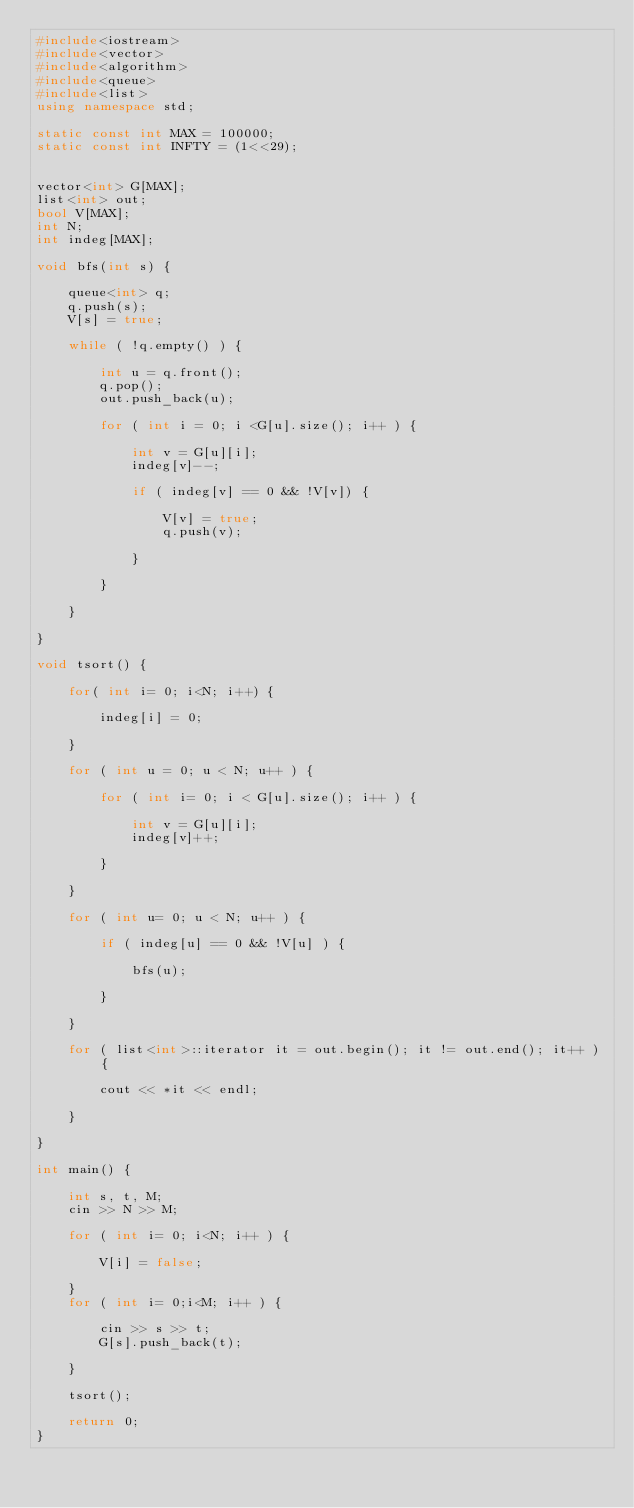Convert code to text. <code><loc_0><loc_0><loc_500><loc_500><_C++_>#include<iostream>
#include<vector>
#include<algorithm>
#include<queue>
#include<list>
using namespace std;

static const int MAX = 100000;
static const int INFTY = (1<<29);


vector<int> G[MAX];
list<int> out;
bool V[MAX];
int N;
int indeg[MAX];

void bfs(int s) {
    
    queue<int> q;
    q.push(s);
    V[s] = true;
    
    while ( !q.empty() ) {
        
        int u = q.front();
        q.pop();
        out.push_back(u);
        
        for ( int i = 0; i <G[u].size(); i++ ) {
            
            int v = G[u][i];
            indeg[v]--;
            
            if ( indeg[v] == 0 && !V[v]) {
                
                V[v] = true;
                q.push(v);
                
            }
            
        }
        
    }
    
}

void tsort() {
    
    for( int i= 0; i<N; i++) {
        
        indeg[i] = 0;
        
    }
    
    for ( int u = 0; u < N; u++ ) {
        
        for ( int i= 0; i < G[u].size(); i++ ) {
            
            int v = G[u][i];
            indeg[v]++;
            
        }
            
    }
    
    for ( int u= 0; u < N; u++ ) {
        
        if ( indeg[u] == 0 && !V[u] ) {
            
            bfs(u);
            
        }
        
    }
    
    for ( list<int>::iterator it = out.begin(); it != out.end(); it++ ) {
        
        cout << *it << endl;
        
    }

}

int main() {
    
    int s, t, M;
    cin >> N >> M;
    
    for ( int i= 0; i<N; i++ ) {
        
        V[i] = false;
        
    }
    for ( int i= 0;i<M; i++ ) {
        
        cin >> s >> t;
        G[s].push_back(t);
        
    }
    
    tsort();
    
    return 0;
}

</code> 